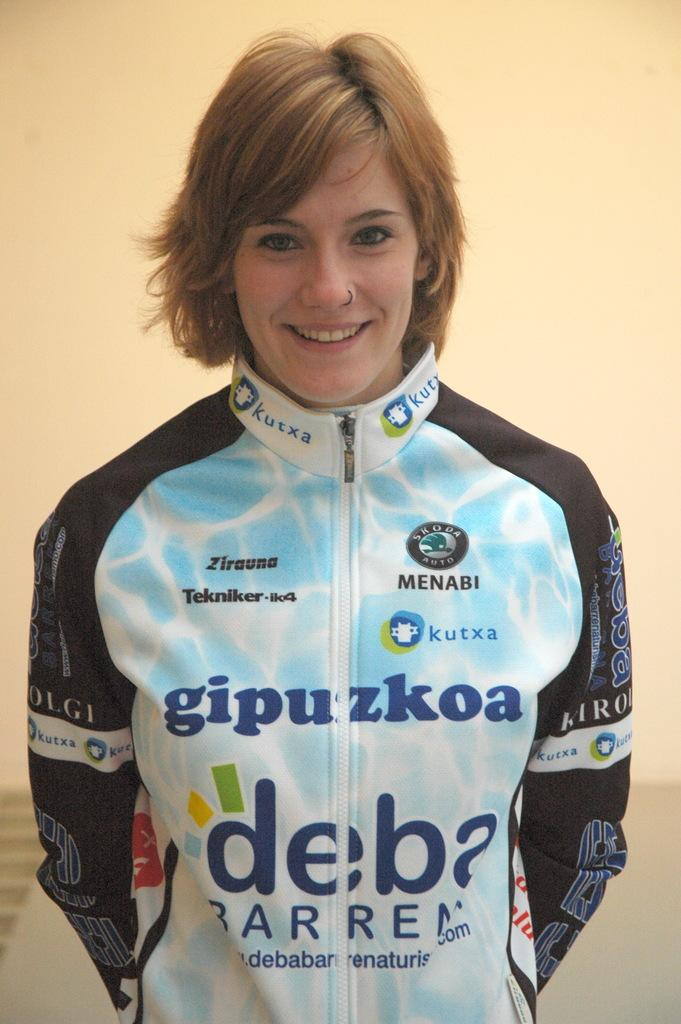Who is the main subject in the image? There is a woman in the image. What is the woman wearing? The woman is wearing a jacket. What is the woman doing in the image? The woman is standing and giving a pose for the picture. What is the woman's facial expression in the image? The woman is smiling. What can be seen in the background of the image? There is a wall in the background of the image. What is the relationship between the woman and her brothers in the image? There is no mention of any brothers in the image, so it is not possible to determine their relationship. 